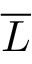Convert formula to latex. <formula><loc_0><loc_0><loc_500><loc_500>\overline { L }</formula> 